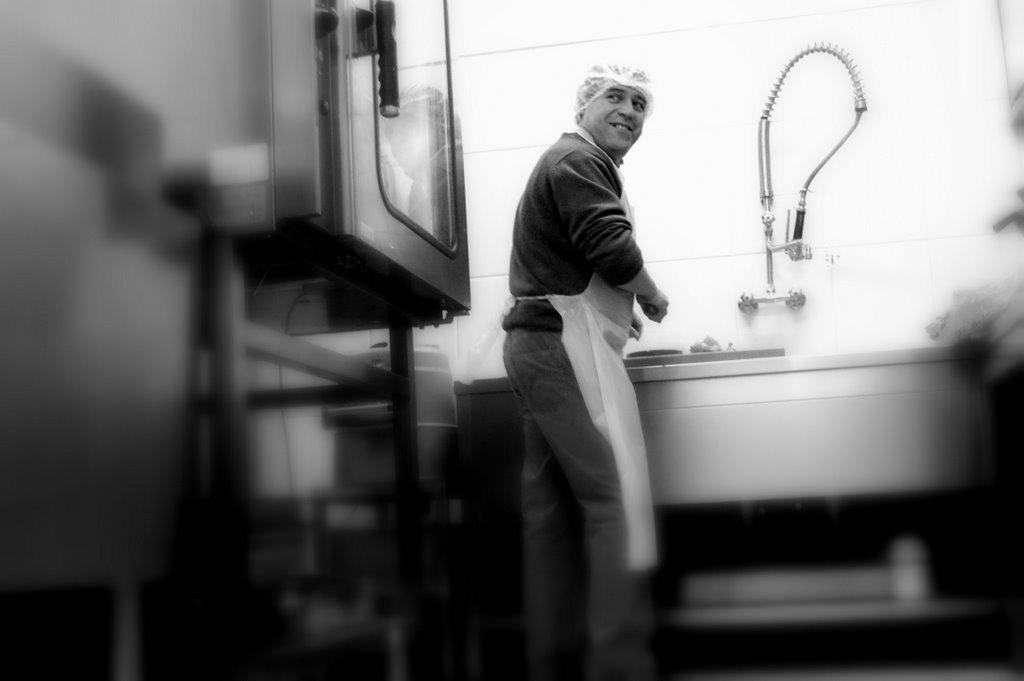What type of structure can be seen in the image? There is a wall in the image. What can be found attached to the wall? There is a pipe and taps attached to the wall. What else is present in the image? There are some objects and a man in the image. Can you describe the man's appearance? The man is wearing a cap and an apron. What is the man doing in the image? The man is standing and smiling. What type of minister is present in the image? There is no minister present in the image. Can you describe the brain activity of the man in the image? There is no information about the man's brain activity in the image. 